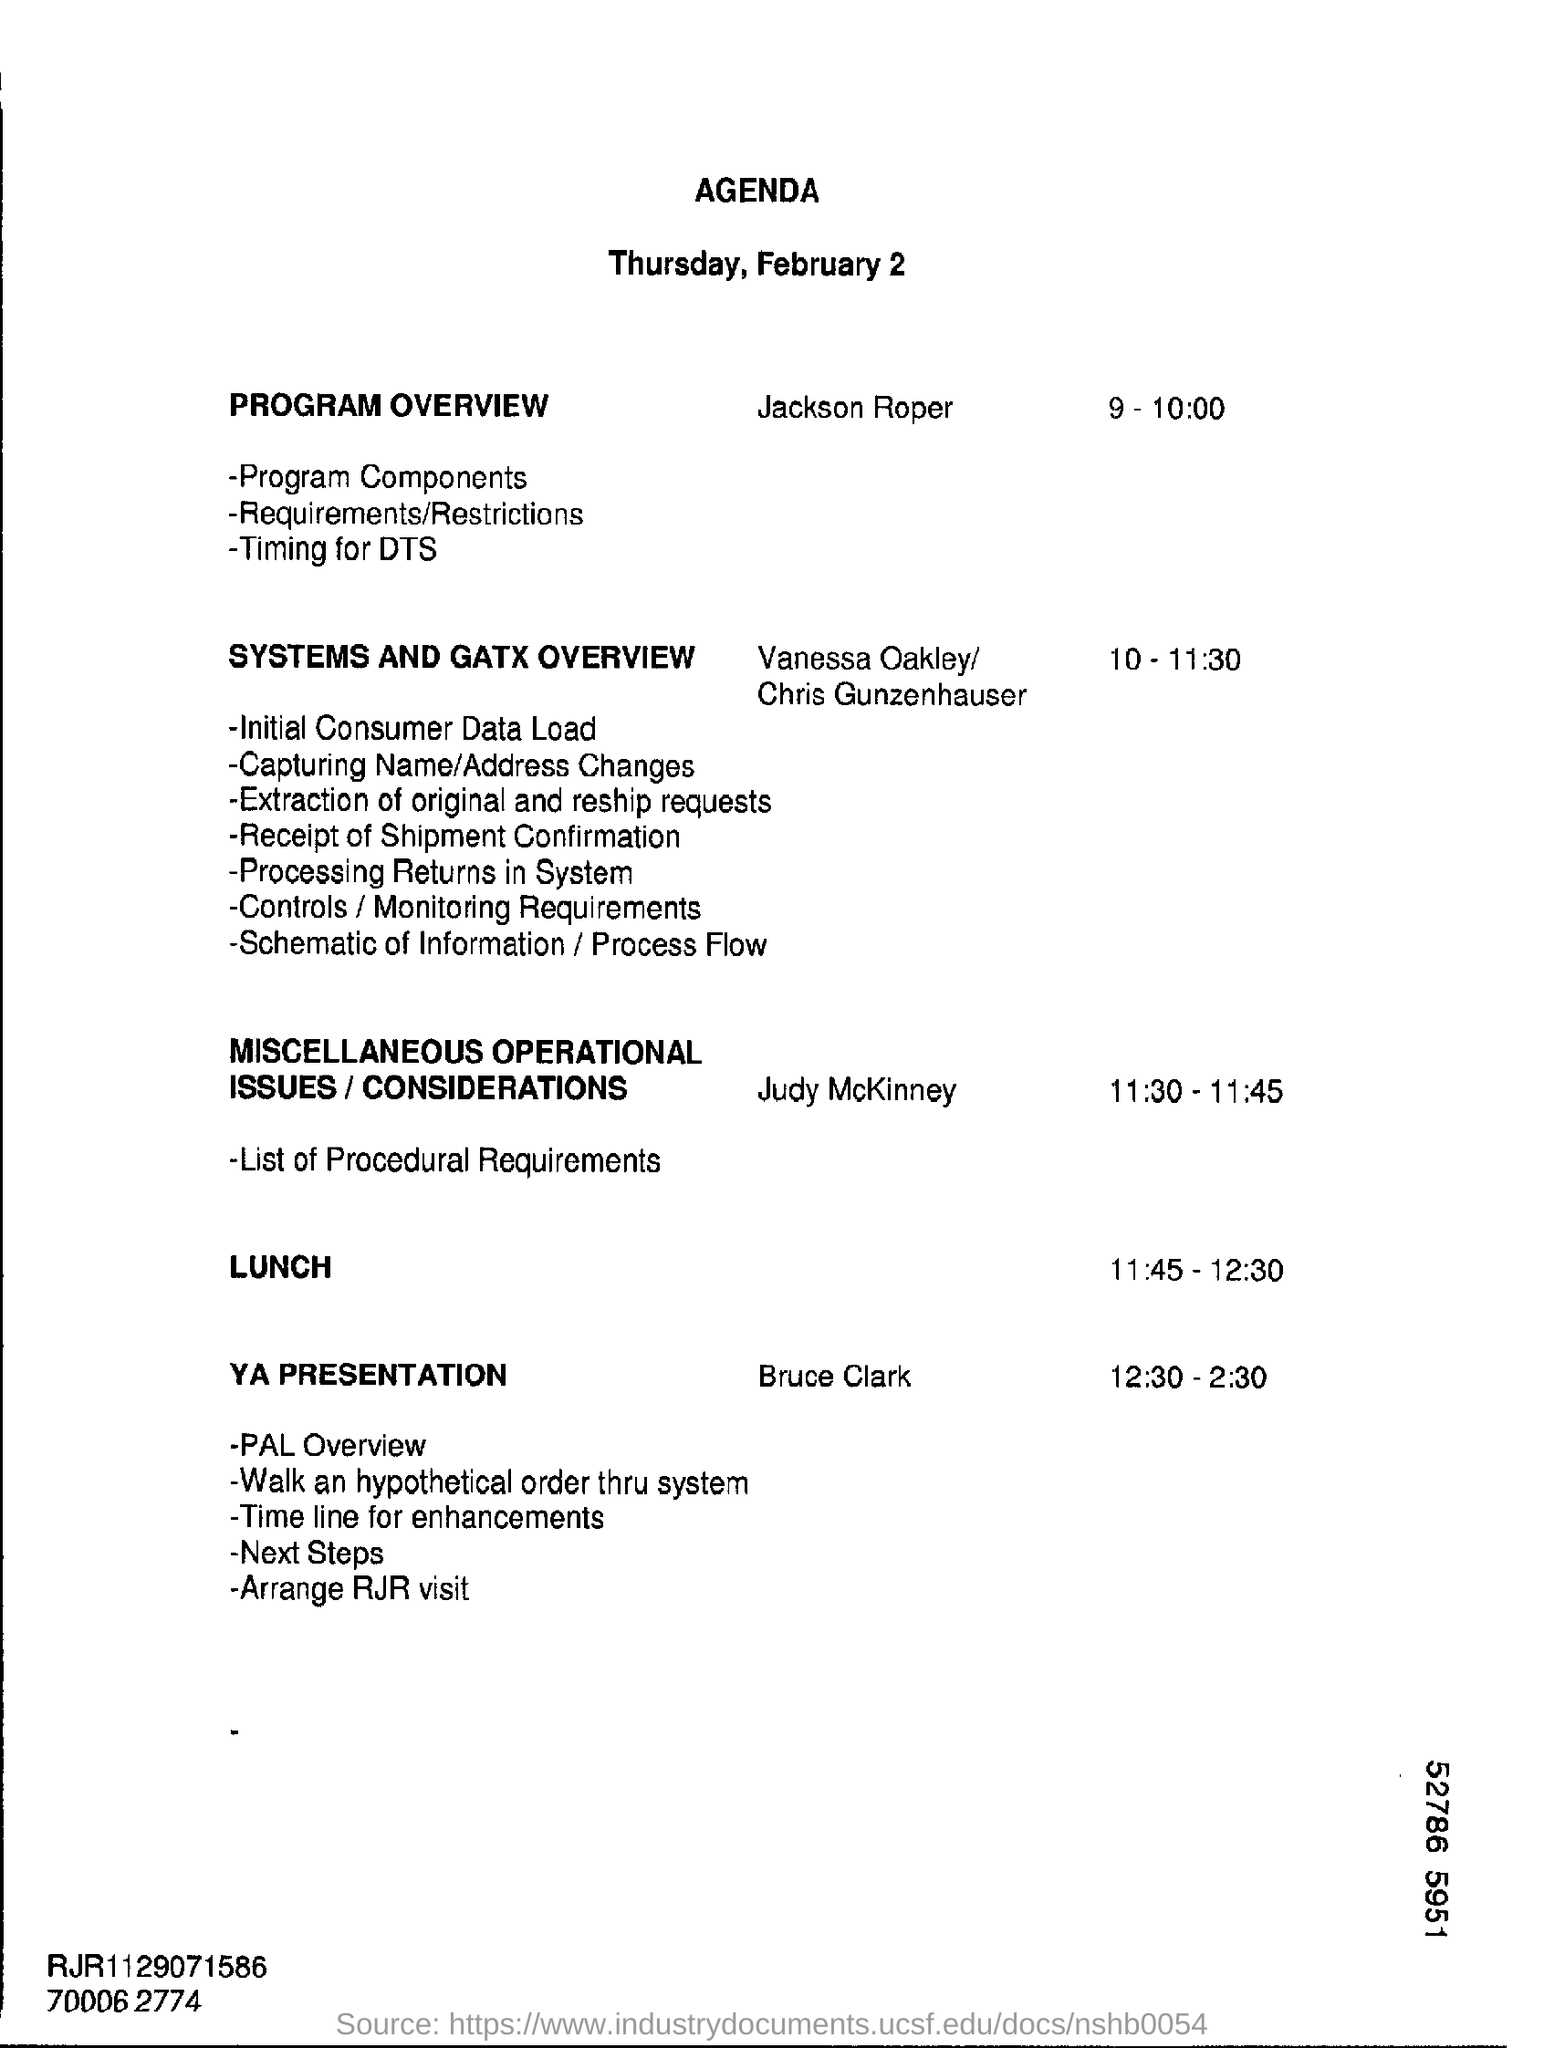What is the date mentioned in the top of the document ?
Provide a short and direct response. Thursday, February 2. What is the date mentioned in the top of the document ?
Your answer should be very brief. Thursday, February 2. What is the Lunch Time ?
Offer a terse response. 11:45-12:30. 